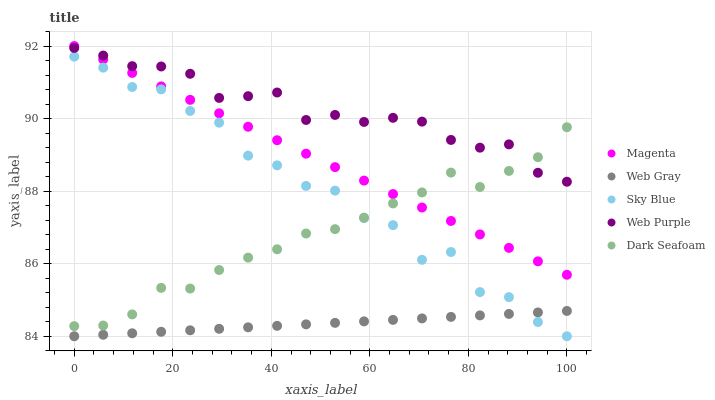Does Web Gray have the minimum area under the curve?
Answer yes or no. Yes. Does Web Purple have the maximum area under the curve?
Answer yes or no. Yes. Does Magenta have the minimum area under the curve?
Answer yes or no. No. Does Magenta have the maximum area under the curve?
Answer yes or no. No. Is Magenta the smoothest?
Answer yes or no. Yes. Is Sky Blue the roughest?
Answer yes or no. Yes. Is Web Gray the smoothest?
Answer yes or no. No. Is Web Gray the roughest?
Answer yes or no. No. Does Sky Blue have the lowest value?
Answer yes or no. Yes. Does Magenta have the lowest value?
Answer yes or no. No. Does Magenta have the highest value?
Answer yes or no. Yes. Does Web Gray have the highest value?
Answer yes or no. No. Is Sky Blue less than Web Purple?
Answer yes or no. Yes. Is Magenta greater than Web Gray?
Answer yes or no. Yes. Does Magenta intersect Dark Seafoam?
Answer yes or no. Yes. Is Magenta less than Dark Seafoam?
Answer yes or no. No. Is Magenta greater than Dark Seafoam?
Answer yes or no. No. Does Sky Blue intersect Web Purple?
Answer yes or no. No. 